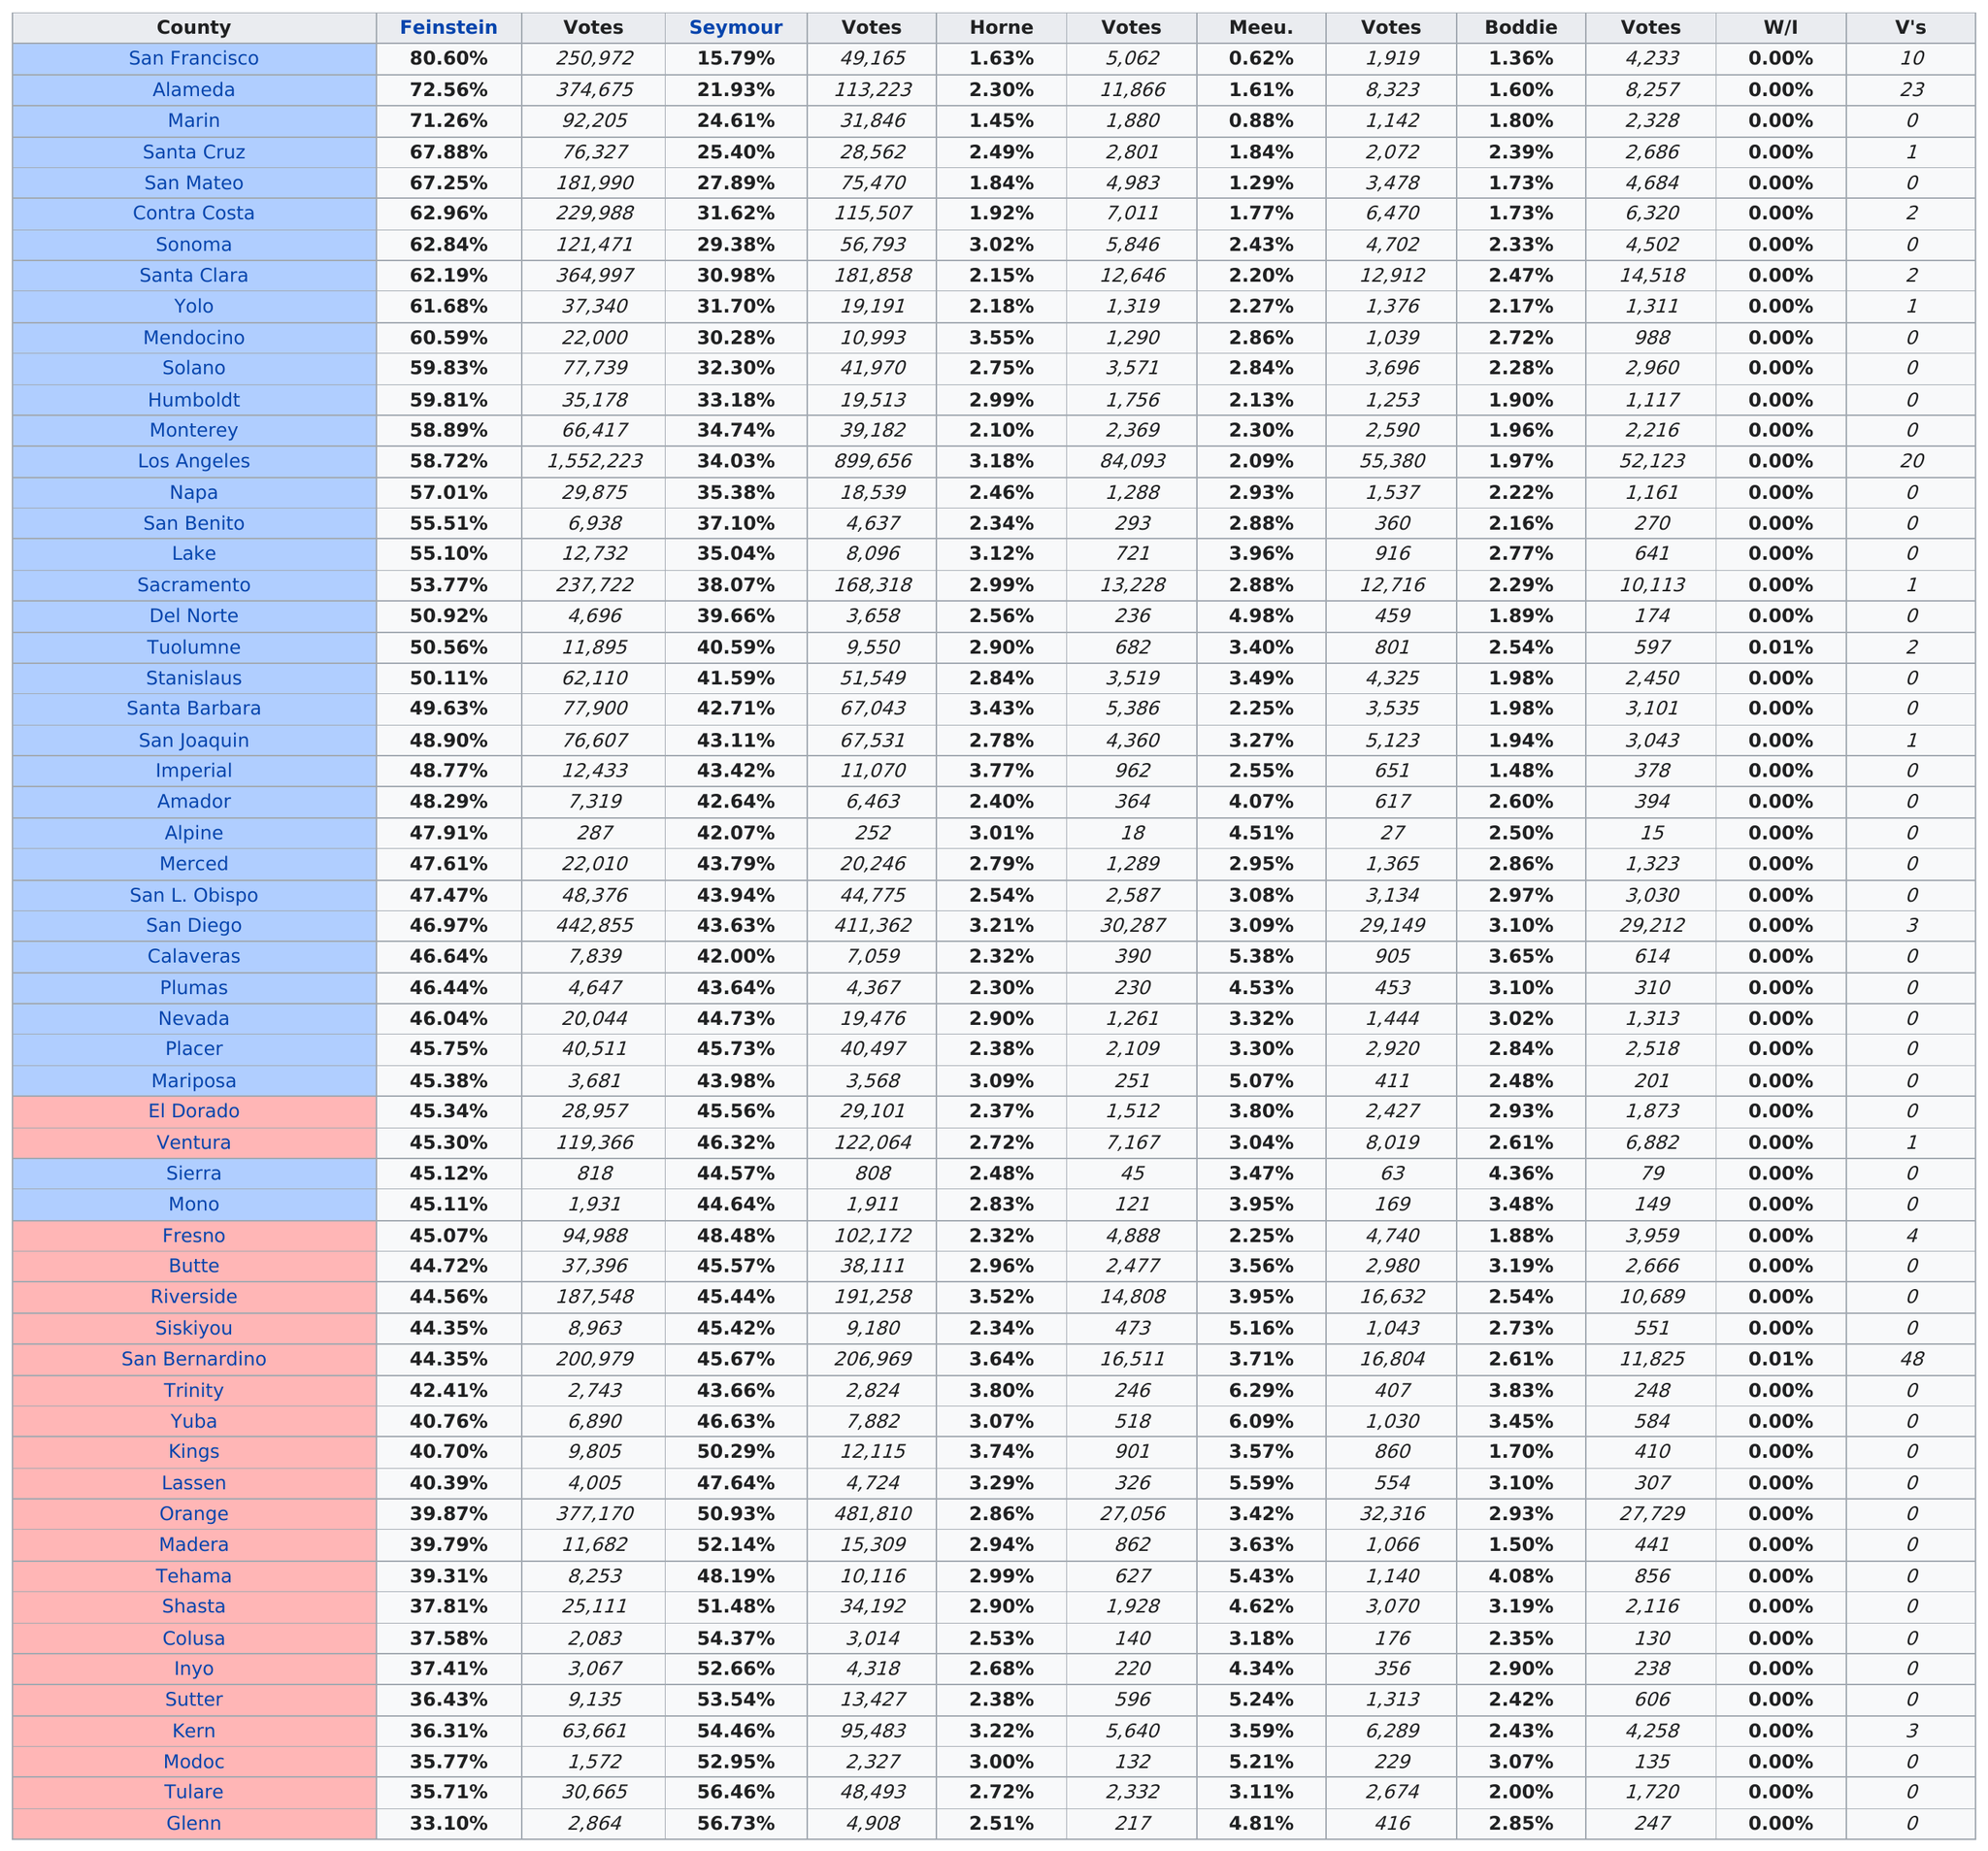List a handful of essential elements in this visual. Horne received 3,571 votes in Solano County. There are counties with more voters than Alameda County. In the election, a total of 58 counties participated. In the election between Horne and his opponent, Alpine County had the least amount of votes for Horne. During the 2020 Senate election, Alpine County had the least amount of votes for Senator Dianne Feinstein. 